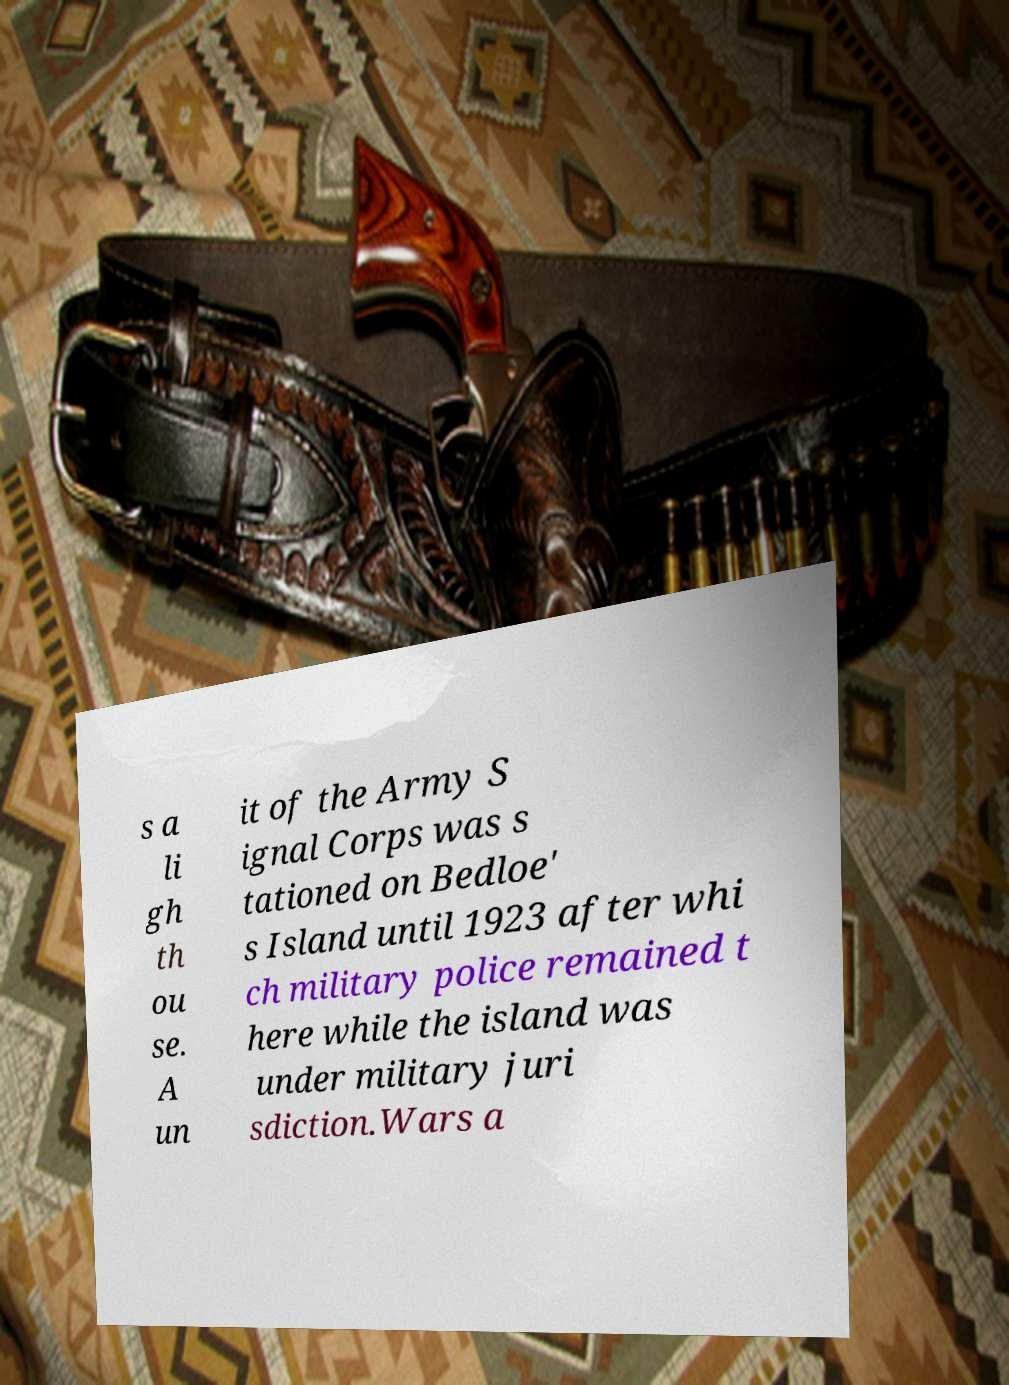For documentation purposes, I need the text within this image transcribed. Could you provide that? s a li gh th ou se. A un it of the Army S ignal Corps was s tationed on Bedloe' s Island until 1923 after whi ch military police remained t here while the island was under military juri sdiction.Wars a 